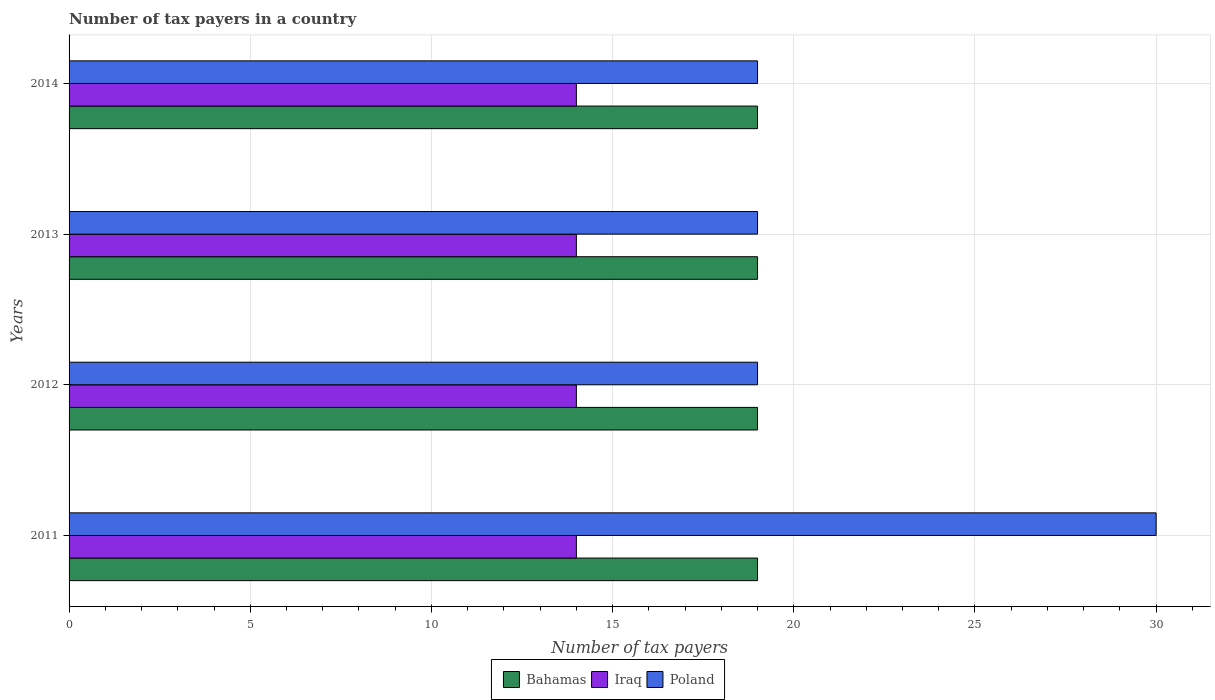How many different coloured bars are there?
Your answer should be very brief. 3. How many groups of bars are there?
Ensure brevity in your answer.  4. Are the number of bars per tick equal to the number of legend labels?
Give a very brief answer. Yes. In how many cases, is the number of bars for a given year not equal to the number of legend labels?
Keep it short and to the point. 0. What is the number of tax payers in in Iraq in 2014?
Ensure brevity in your answer.  14. Across all years, what is the maximum number of tax payers in in Poland?
Your answer should be very brief. 30. Across all years, what is the minimum number of tax payers in in Poland?
Provide a succinct answer. 19. What is the total number of tax payers in in Poland in the graph?
Make the answer very short. 87. What is the difference between the number of tax payers in in Bahamas in 2014 and the number of tax payers in in Iraq in 2013?
Give a very brief answer. 5. What is the average number of tax payers in in Iraq per year?
Provide a short and direct response. 14. In the year 2011, what is the difference between the number of tax payers in in Poland and number of tax payers in in Iraq?
Your answer should be compact. 16. What is the ratio of the number of tax payers in in Iraq in 2011 to that in 2014?
Make the answer very short. 1. Is the difference between the number of tax payers in in Poland in 2012 and 2014 greater than the difference between the number of tax payers in in Iraq in 2012 and 2014?
Keep it short and to the point. No. What does the 1st bar from the top in 2014 represents?
Give a very brief answer. Poland. What does the 3rd bar from the bottom in 2013 represents?
Provide a short and direct response. Poland. Are all the bars in the graph horizontal?
Give a very brief answer. Yes. How many years are there in the graph?
Keep it short and to the point. 4. What is the difference between two consecutive major ticks on the X-axis?
Offer a terse response. 5. Are the values on the major ticks of X-axis written in scientific E-notation?
Your answer should be very brief. No. How are the legend labels stacked?
Provide a succinct answer. Horizontal. What is the title of the graph?
Provide a succinct answer. Number of tax payers in a country. Does "Kiribati" appear as one of the legend labels in the graph?
Your answer should be compact. No. What is the label or title of the X-axis?
Give a very brief answer. Number of tax payers. What is the Number of tax payers in Poland in 2011?
Offer a terse response. 30. What is the Number of tax payers of Iraq in 2012?
Provide a short and direct response. 14. What is the Number of tax payers in Bahamas in 2013?
Make the answer very short. 19. What is the Number of tax payers of Poland in 2013?
Your answer should be compact. 19. What is the Number of tax payers of Bahamas in 2014?
Your response must be concise. 19. What is the Number of tax payers of Iraq in 2014?
Provide a succinct answer. 14. What is the Number of tax payers in Poland in 2014?
Offer a terse response. 19. Across all years, what is the maximum Number of tax payers of Poland?
Keep it short and to the point. 30. What is the total Number of tax payers in Bahamas in the graph?
Provide a short and direct response. 76. What is the total Number of tax payers of Iraq in the graph?
Make the answer very short. 56. What is the difference between the Number of tax payers in Bahamas in 2011 and that in 2012?
Provide a succinct answer. 0. What is the difference between the Number of tax payers of Poland in 2011 and that in 2013?
Offer a very short reply. 11. What is the difference between the Number of tax payers in Bahamas in 2011 and that in 2014?
Offer a terse response. 0. What is the difference between the Number of tax payers in Poland in 2011 and that in 2014?
Offer a terse response. 11. What is the difference between the Number of tax payers in Poland in 2012 and that in 2013?
Keep it short and to the point. 0. What is the difference between the Number of tax payers in Poland in 2012 and that in 2014?
Ensure brevity in your answer.  0. What is the difference between the Number of tax payers in Poland in 2013 and that in 2014?
Provide a short and direct response. 0. What is the difference between the Number of tax payers of Bahamas in 2011 and the Number of tax payers of Iraq in 2012?
Ensure brevity in your answer.  5. What is the difference between the Number of tax payers of Bahamas in 2011 and the Number of tax payers of Poland in 2012?
Provide a short and direct response. 0. What is the difference between the Number of tax payers of Iraq in 2011 and the Number of tax payers of Poland in 2012?
Your answer should be compact. -5. What is the difference between the Number of tax payers of Bahamas in 2011 and the Number of tax payers of Poland in 2013?
Provide a short and direct response. 0. What is the difference between the Number of tax payers in Iraq in 2011 and the Number of tax payers in Poland in 2013?
Your answer should be very brief. -5. What is the difference between the Number of tax payers of Iraq in 2011 and the Number of tax payers of Poland in 2014?
Provide a succinct answer. -5. What is the difference between the Number of tax payers in Bahamas in 2012 and the Number of tax payers in Iraq in 2013?
Make the answer very short. 5. What is the difference between the Number of tax payers of Bahamas in 2012 and the Number of tax payers of Poland in 2013?
Ensure brevity in your answer.  0. What is the difference between the Number of tax payers in Bahamas in 2012 and the Number of tax payers in Iraq in 2014?
Your answer should be compact. 5. What is the difference between the Number of tax payers of Bahamas in 2012 and the Number of tax payers of Poland in 2014?
Your answer should be very brief. 0. What is the difference between the Number of tax payers in Iraq in 2012 and the Number of tax payers in Poland in 2014?
Provide a short and direct response. -5. What is the difference between the Number of tax payers in Iraq in 2013 and the Number of tax payers in Poland in 2014?
Make the answer very short. -5. What is the average Number of tax payers of Bahamas per year?
Offer a terse response. 19. What is the average Number of tax payers in Iraq per year?
Your response must be concise. 14. What is the average Number of tax payers in Poland per year?
Your answer should be very brief. 21.75. In the year 2012, what is the difference between the Number of tax payers of Bahamas and Number of tax payers of Poland?
Offer a terse response. 0. In the year 2013, what is the difference between the Number of tax payers in Bahamas and Number of tax payers in Poland?
Give a very brief answer. 0. In the year 2014, what is the difference between the Number of tax payers in Bahamas and Number of tax payers in Iraq?
Provide a succinct answer. 5. In the year 2014, what is the difference between the Number of tax payers in Bahamas and Number of tax payers in Poland?
Your response must be concise. 0. In the year 2014, what is the difference between the Number of tax payers in Iraq and Number of tax payers in Poland?
Provide a short and direct response. -5. What is the ratio of the Number of tax payers in Bahamas in 2011 to that in 2012?
Provide a succinct answer. 1. What is the ratio of the Number of tax payers of Poland in 2011 to that in 2012?
Your answer should be very brief. 1.58. What is the ratio of the Number of tax payers in Poland in 2011 to that in 2013?
Your answer should be compact. 1.58. What is the ratio of the Number of tax payers of Bahamas in 2011 to that in 2014?
Offer a terse response. 1. What is the ratio of the Number of tax payers of Poland in 2011 to that in 2014?
Provide a short and direct response. 1.58. What is the ratio of the Number of tax payers in Iraq in 2012 to that in 2013?
Provide a succinct answer. 1. What is the ratio of the Number of tax payers of Poland in 2012 to that in 2013?
Make the answer very short. 1. What is the ratio of the Number of tax payers of Bahamas in 2012 to that in 2014?
Offer a terse response. 1. What is the ratio of the Number of tax payers in Poland in 2012 to that in 2014?
Ensure brevity in your answer.  1. What is the ratio of the Number of tax payers of Iraq in 2013 to that in 2014?
Give a very brief answer. 1. What is the ratio of the Number of tax payers of Poland in 2013 to that in 2014?
Provide a short and direct response. 1. What is the difference between the highest and the lowest Number of tax payers of Bahamas?
Provide a short and direct response. 0. What is the difference between the highest and the lowest Number of tax payers in Poland?
Ensure brevity in your answer.  11. 